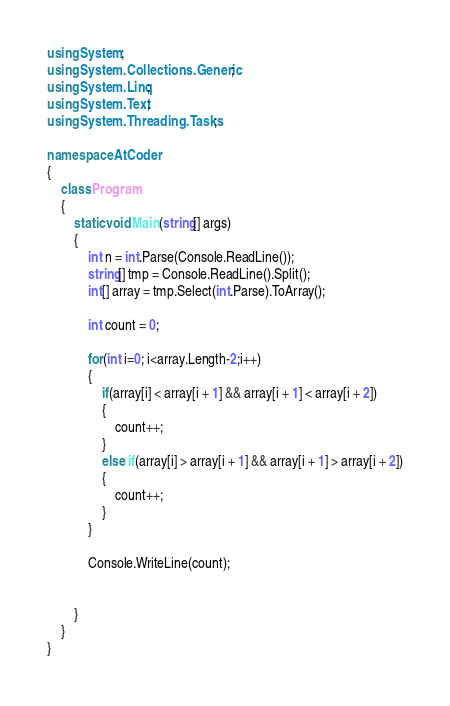<code> <loc_0><loc_0><loc_500><loc_500><_C#_>using System;
using System.Collections.Generic;
using System.Linq;
using System.Text;
using System.Threading.Tasks;

namespace AtCoder
{
    class Program
    {
        static void Main(string[] args)
        {
            int n = int.Parse(Console.ReadLine());
            string[] tmp = Console.ReadLine().Split();
            int[] array = tmp.Select(int.Parse).ToArray();

            int count = 0;

            for(int i=0; i<array.Length-2;i++)
            {
                if(array[i] < array[i + 1] && array[i + 1] < array[i + 2])
                {
                    count++;
                }
                else if(array[i] > array[i + 1] && array[i + 1] > array[i + 2])
                {
                    count++;
                }
            }

            Console.WriteLine(count);

            
        }
    }
}
</code> 